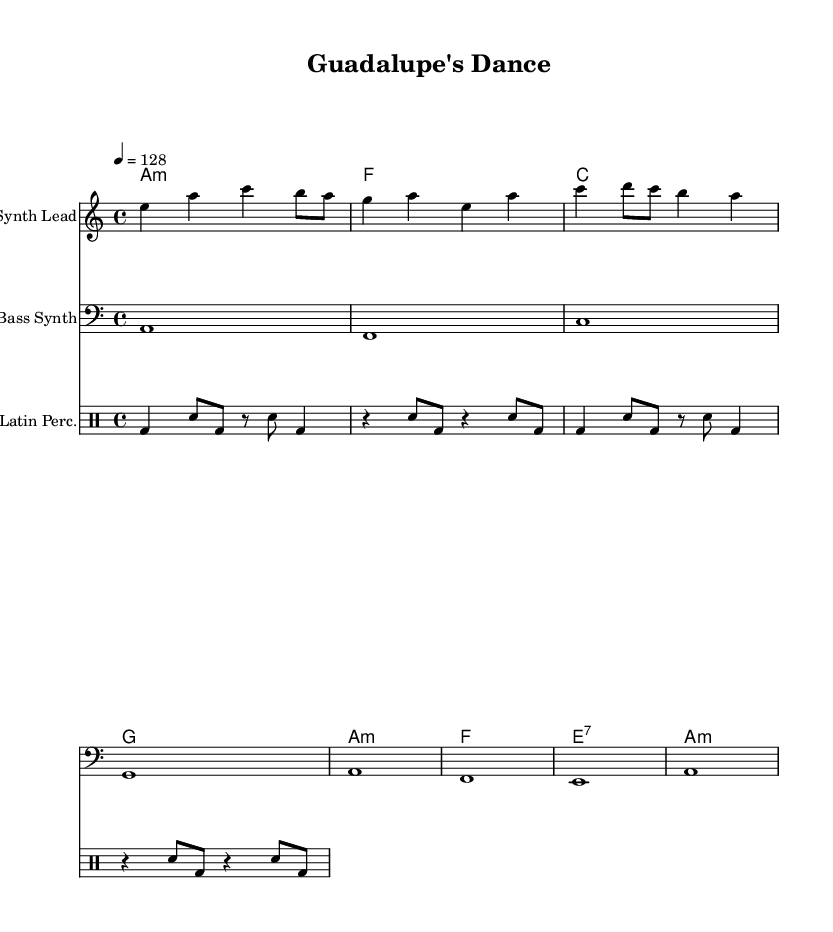What is the key signature of this music? The key signature indicates that the piece is in A minor, which is represented by no sharps or flats on the staff. This is confirmed by the note 'a' being the tonic in the melody and harmony sections.
Answer: A minor What is the time signature of this music? The time signature shown is 4/4, which is indicated at the beginning of the score and means there are four beats in each measure, and the quarter note gets one beat.
Answer: 4/4 What is the tempo marking of this piece? The tempo marking reads "4 = 128," which means that the quarter note is counted at a speed of 128 beats per minute. This provides the piece with an upbeat and lively feel typical of electronic dance music.
Answer: 128 How many measures are present in the melody section? The melody section consists of two measures based on visual analysis of the notes grouped within the staff and counting each complete set of four beats.
Answer: 2 What chord type is used on the first measure of the harmony? The first chord in the harmony is an A minor chord, which can be identified by the notation 'a1:m' indicating a minor chord based on the note A.
Answer: A minor What type of rhythm is primarily used in the percussion section? The rhythm in the percussion section follows a traditional Latin pattern, highlighting the use of bass drum and snare drum in a syncopated way that exemplifies the style of Latin-infused electronic music.
Answer: Latin What instrument is specified for the bass line? The instrument indicated for the bass line section in the score is the "Bass Synth," which is explicitly labeled at the beginning of the staff under the bass line notes.
Answer: Bass Synth 